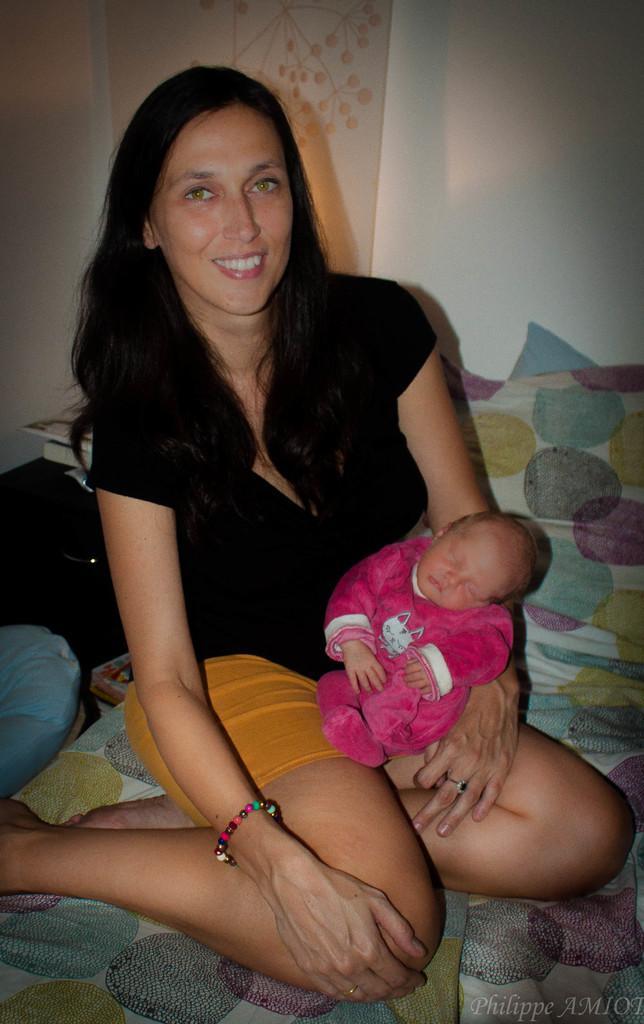Please provide a concise description of this image. In the center of the image there is a lady holding a baby. She is sitting on the bed. In the background of the image there is wall. 